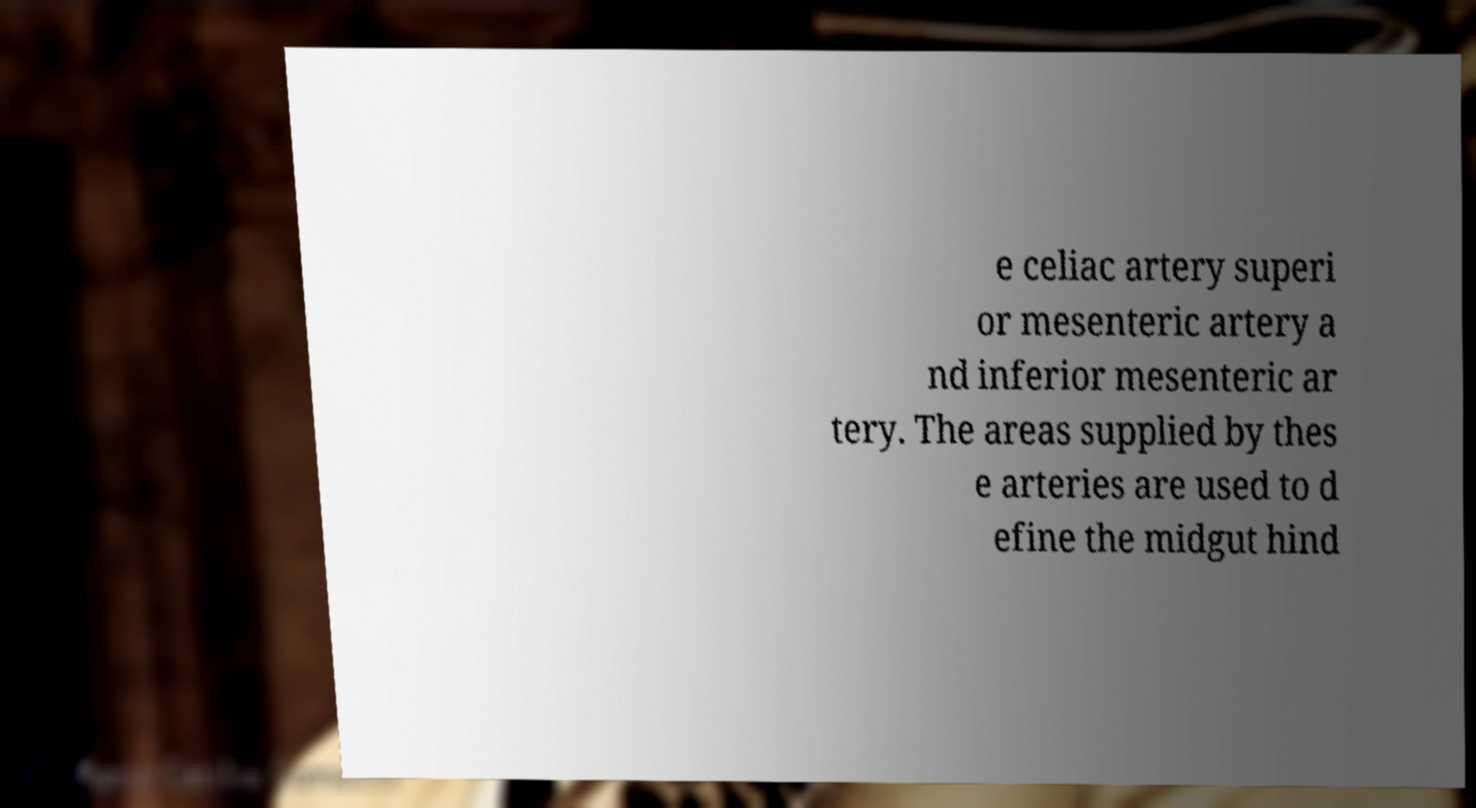Please read and relay the text visible in this image. What does it say? e celiac artery superi or mesenteric artery a nd inferior mesenteric ar tery. The areas supplied by thes e arteries are used to d efine the midgut hind 